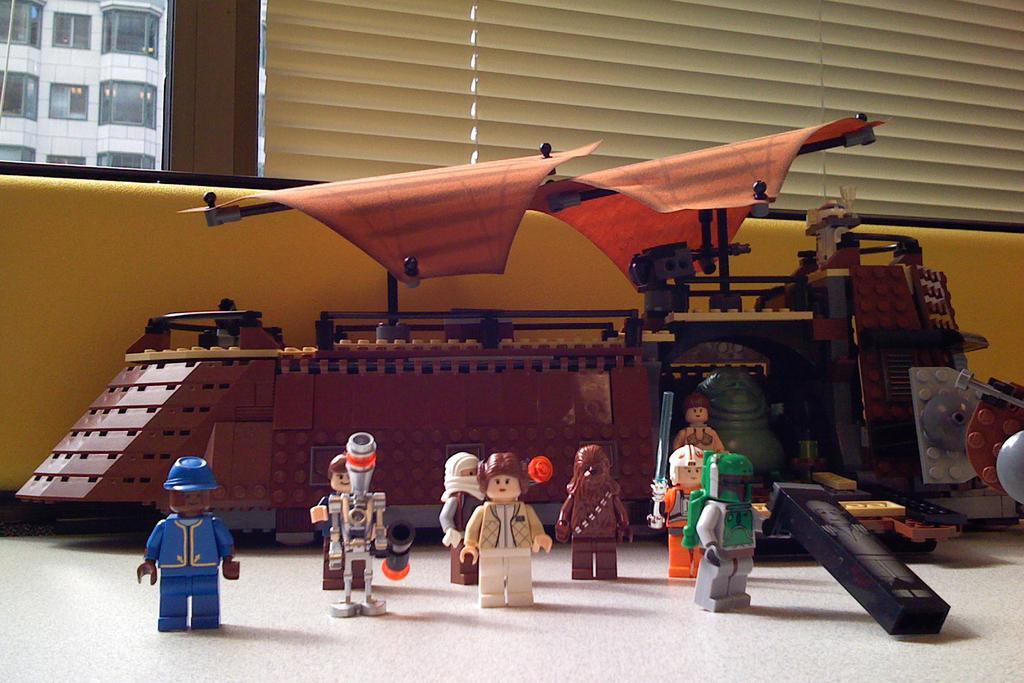Please provide a concise description of this image. In this image, we can see toys on the white surface. Here there is a vehicle. Background we can see wall, windows, window shades. Here we can see glass. Through the glass we can see the outside view. Here there is a building. 